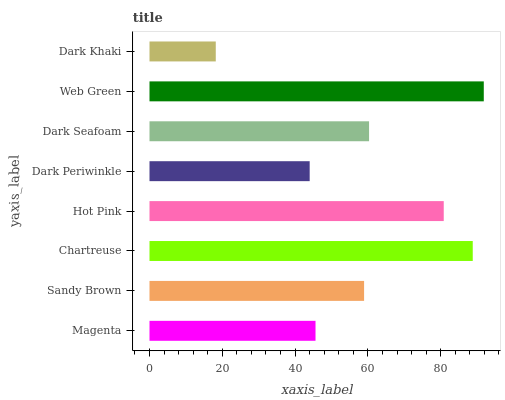Is Dark Khaki the minimum?
Answer yes or no. Yes. Is Web Green the maximum?
Answer yes or no. Yes. Is Sandy Brown the minimum?
Answer yes or no. No. Is Sandy Brown the maximum?
Answer yes or no. No. Is Sandy Brown greater than Magenta?
Answer yes or no. Yes. Is Magenta less than Sandy Brown?
Answer yes or no. Yes. Is Magenta greater than Sandy Brown?
Answer yes or no. No. Is Sandy Brown less than Magenta?
Answer yes or no. No. Is Dark Seafoam the high median?
Answer yes or no. Yes. Is Sandy Brown the low median?
Answer yes or no. Yes. Is Dark Khaki the high median?
Answer yes or no. No. Is Dark Seafoam the low median?
Answer yes or no. No. 